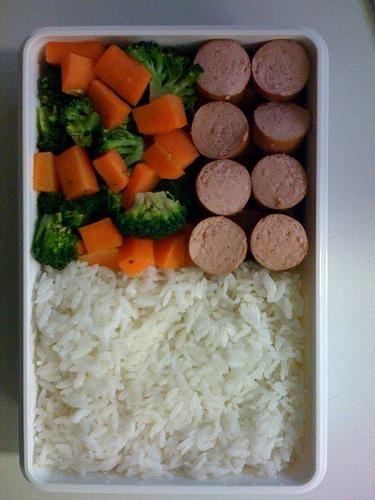What is the white stuff on the food?
Give a very brief answer. Rice. What is mainly feature?
Answer briefly. Rice. How many sausages are on the tray?
Be succinct. 8. What are these?
Quick response, please. Food. What food is on the top left?
Short answer required. Carrots. What color is the knife handle?
Concise answer only. No knife. How many eggs are in the box?
Give a very brief answer. 0. Do you see cheese?
Concise answer only. No. What is the orange food?
Short answer required. Carrots. Are these vegetables?
Short answer required. Yes. Where are the apples?
Keep it brief. Nowhere. What cooking technique was used to prepare the sausage?
Concise answer only. Boiling. How many carrots are there?
Quick response, please. 15. What is in the upper left hand picture?
Give a very brief answer. Vegetables. Is any meat on the tray?
Be succinct. Yes. How many compartments are there?
Concise answer only. 3. What is the white food?
Give a very brief answer. Rice. Does this dish contain any meat?
Write a very short answer. Yes. Which of the 4 major food groups are missing?
Write a very short answer. Dairy. What is in the picture?
Concise answer only. Food. 